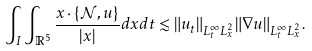<formula> <loc_0><loc_0><loc_500><loc_500>\int _ { I } \int _ { \mathbb { R } ^ { 5 } } \frac { x \cdot \{ \mathcal { N } , u \} } { | x | } d x d t & \lesssim \| u _ { t } \| _ { L _ { t } ^ { \infty } L _ { x } ^ { 2 } } \| \nabla u \| _ { L _ { t } ^ { \infty } L _ { x } ^ { 2 } } .</formula> 